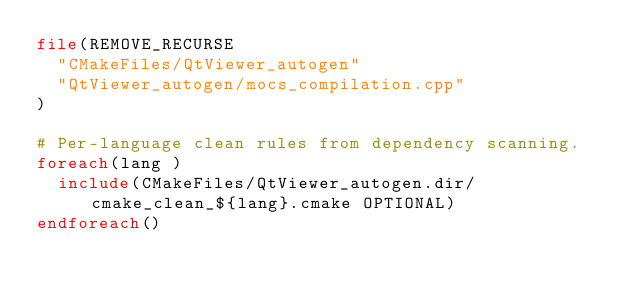<code> <loc_0><loc_0><loc_500><loc_500><_CMake_>file(REMOVE_RECURSE
  "CMakeFiles/QtViewer_autogen"
  "QtViewer_autogen/mocs_compilation.cpp"
)

# Per-language clean rules from dependency scanning.
foreach(lang )
  include(CMakeFiles/QtViewer_autogen.dir/cmake_clean_${lang}.cmake OPTIONAL)
endforeach()
</code> 